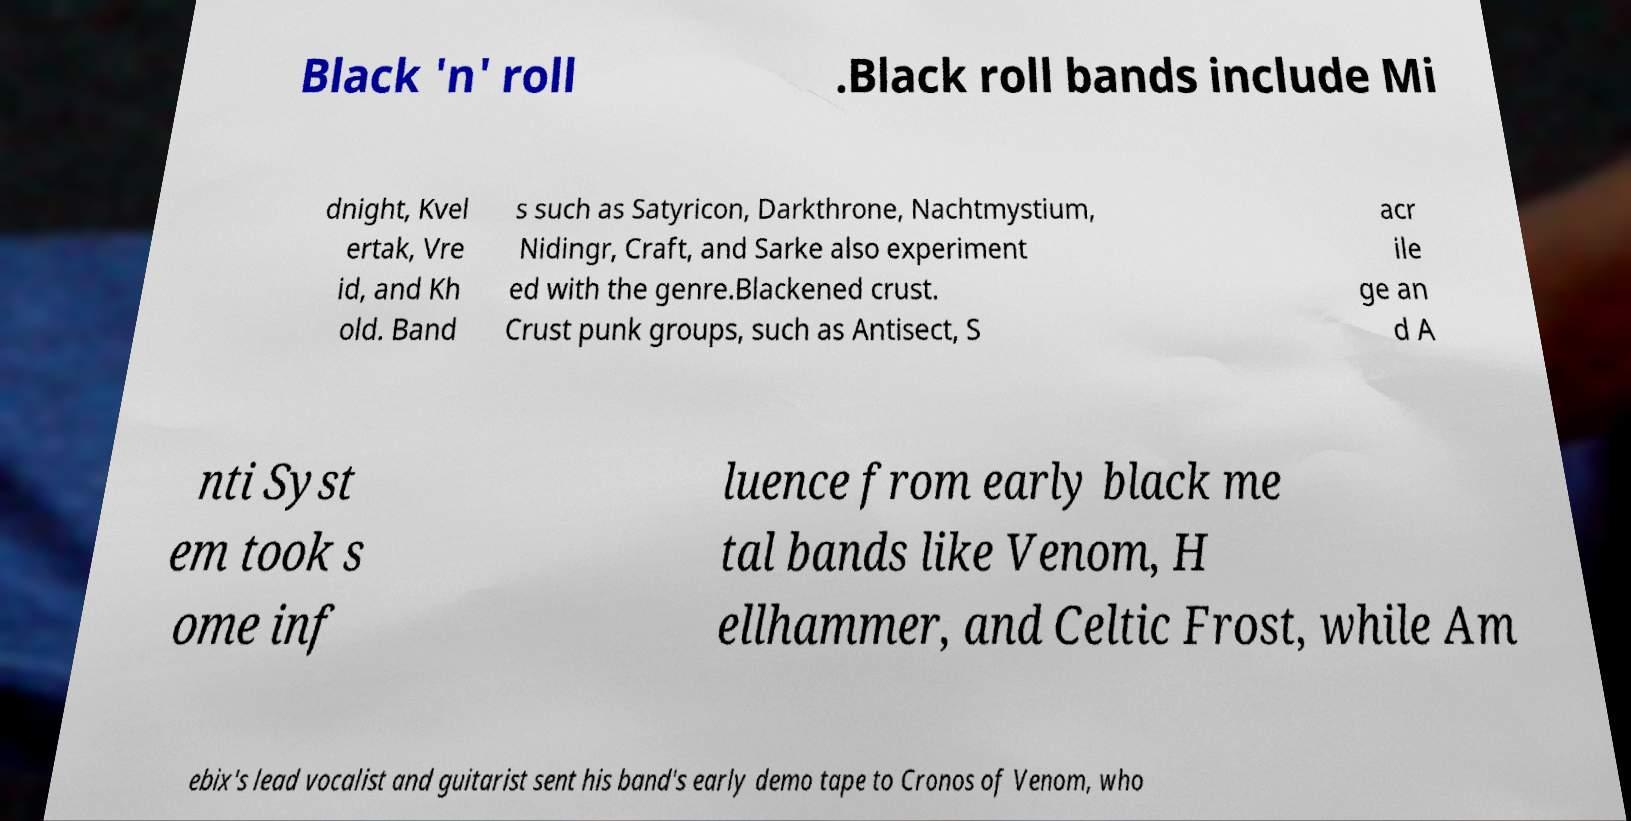Can you read and provide the text displayed in the image?This photo seems to have some interesting text. Can you extract and type it out for me? Black 'n' roll .Black roll bands include Mi dnight, Kvel ertak, Vre id, and Kh old. Band s such as Satyricon, Darkthrone, Nachtmystium, Nidingr, Craft, and Sarke also experiment ed with the genre.Blackened crust. Crust punk groups, such as Antisect, S acr ile ge an d A nti Syst em took s ome inf luence from early black me tal bands like Venom, H ellhammer, and Celtic Frost, while Am ebix's lead vocalist and guitarist sent his band's early demo tape to Cronos of Venom, who 